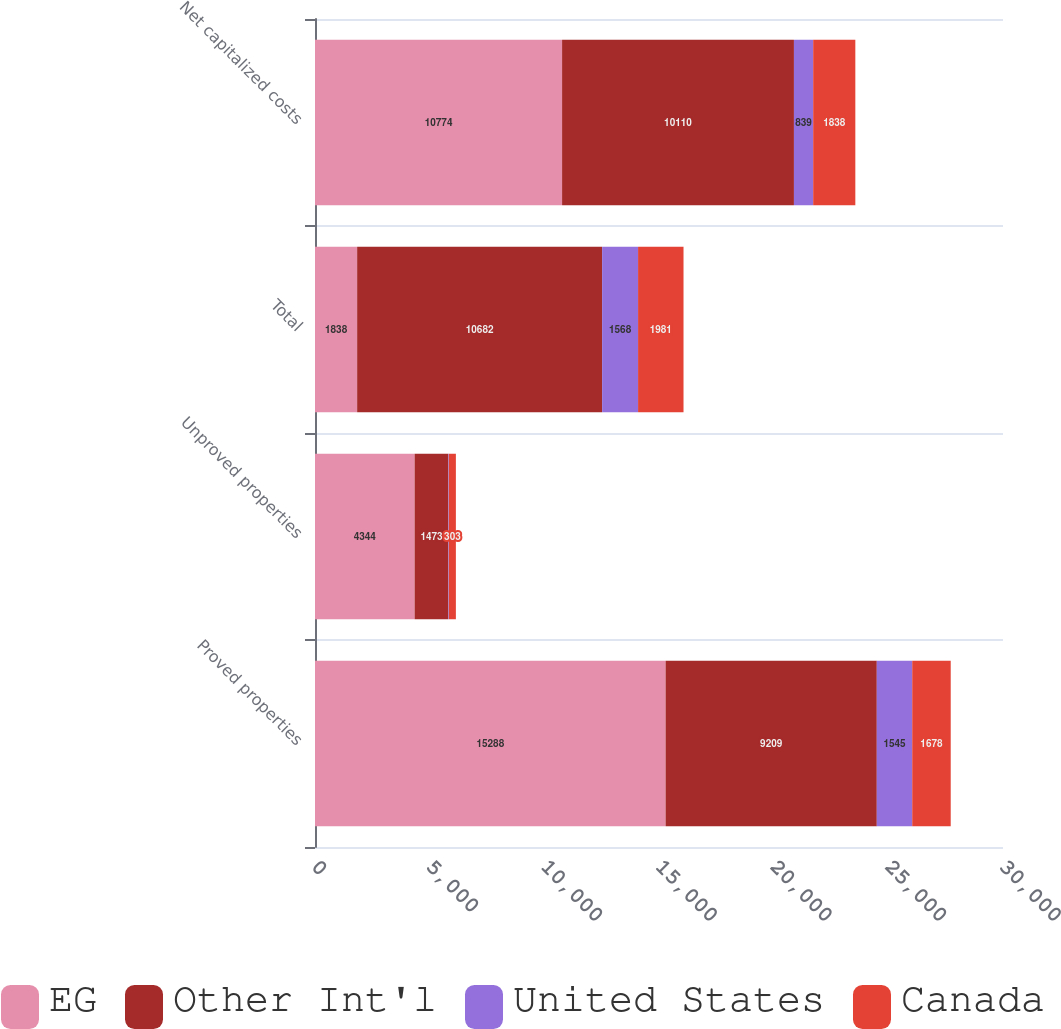Convert chart. <chart><loc_0><loc_0><loc_500><loc_500><stacked_bar_chart><ecel><fcel>Proved properties<fcel>Unproved properties<fcel>Total<fcel>Net capitalized costs<nl><fcel>EG<fcel>15288<fcel>4344<fcel>1838<fcel>10774<nl><fcel>Other Int'l<fcel>9209<fcel>1473<fcel>10682<fcel>10110<nl><fcel>United States<fcel>1545<fcel>23<fcel>1568<fcel>839<nl><fcel>Canada<fcel>1678<fcel>303<fcel>1981<fcel>1838<nl></chart> 